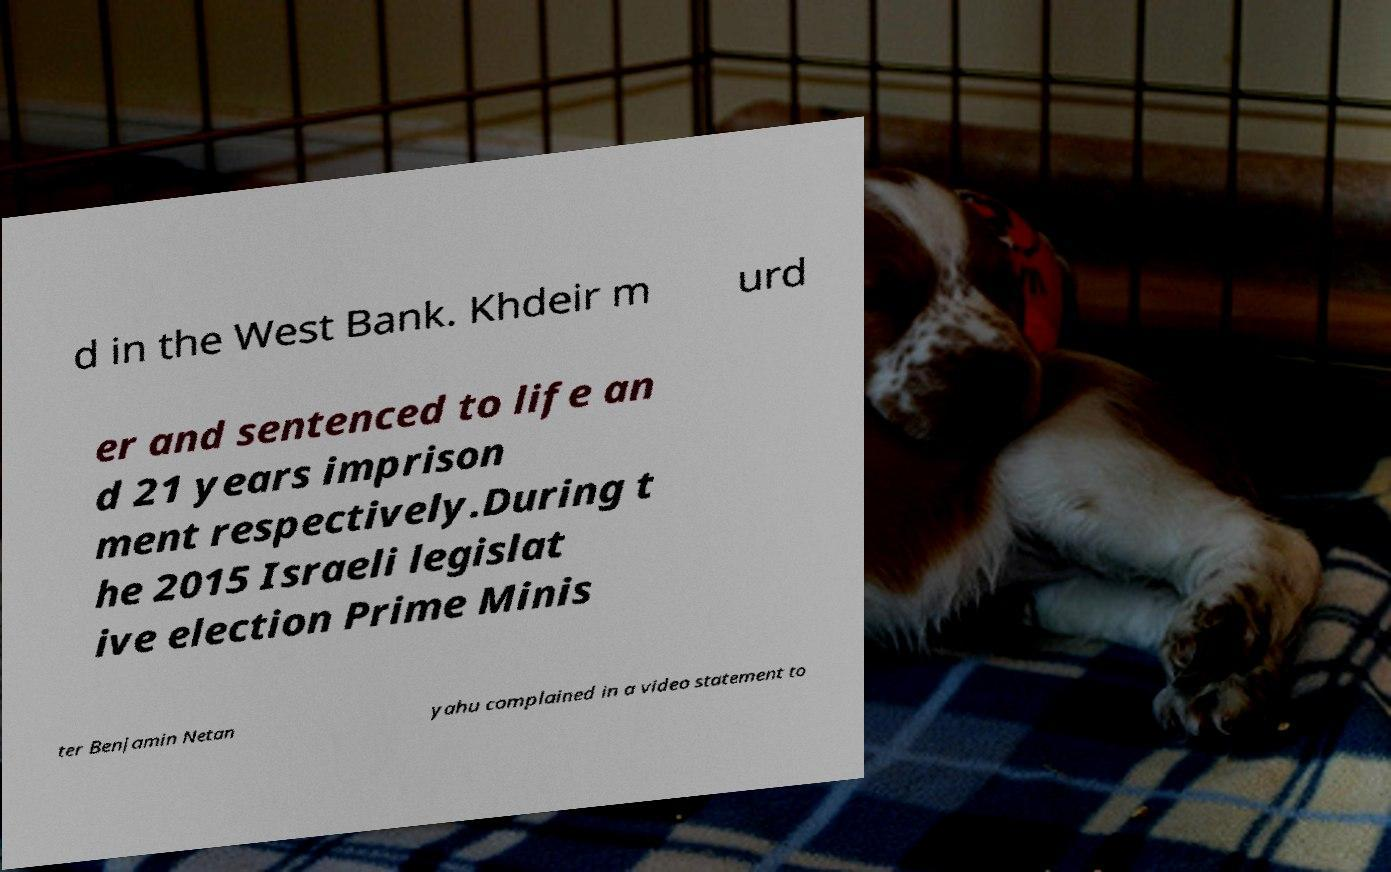What messages or text are displayed in this image? I need them in a readable, typed format. d in the West Bank. Khdeir m urd er and sentenced to life an d 21 years imprison ment respectively.During t he 2015 Israeli legislat ive election Prime Minis ter Benjamin Netan yahu complained in a video statement to 